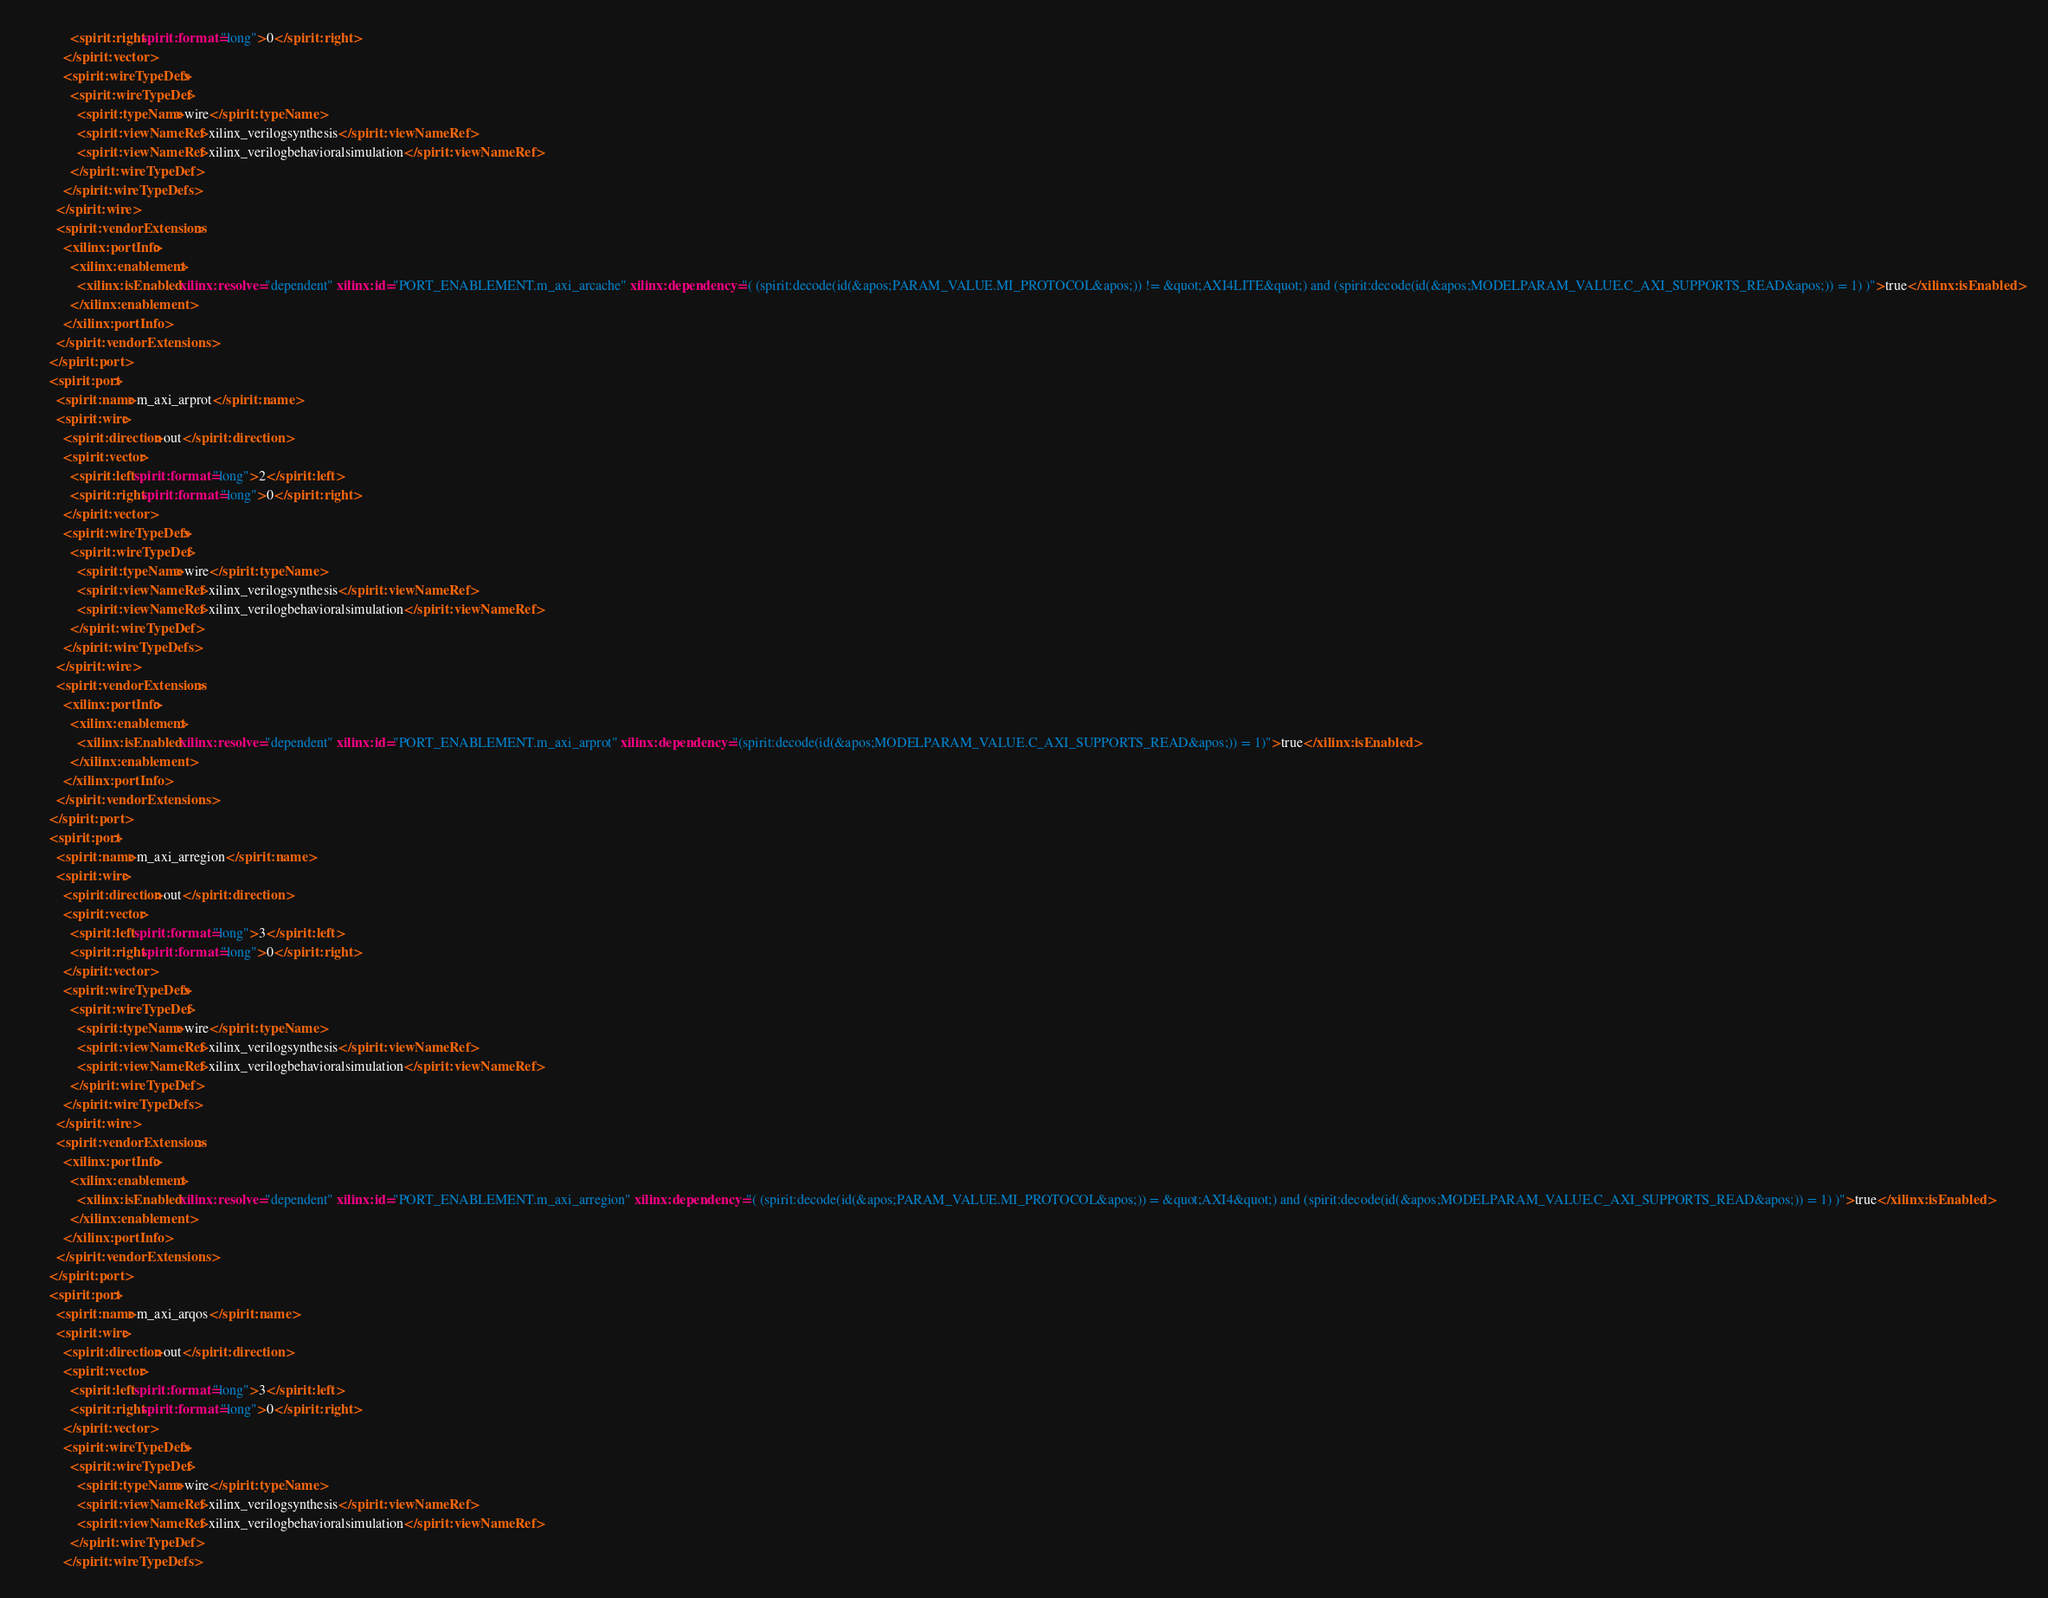Convert code to text. <code><loc_0><loc_0><loc_500><loc_500><_XML_>            <spirit:right spirit:format="long">0</spirit:right>
          </spirit:vector>
          <spirit:wireTypeDefs>
            <spirit:wireTypeDef>
              <spirit:typeName>wire</spirit:typeName>
              <spirit:viewNameRef>xilinx_verilogsynthesis</spirit:viewNameRef>
              <spirit:viewNameRef>xilinx_verilogbehavioralsimulation</spirit:viewNameRef>
            </spirit:wireTypeDef>
          </spirit:wireTypeDefs>
        </spirit:wire>
        <spirit:vendorExtensions>
          <xilinx:portInfo>
            <xilinx:enablement>
              <xilinx:isEnabled xilinx:resolve="dependent" xilinx:id="PORT_ENABLEMENT.m_axi_arcache" xilinx:dependency="( (spirit:decode(id(&apos;PARAM_VALUE.MI_PROTOCOL&apos;)) != &quot;AXI4LITE&quot;) and (spirit:decode(id(&apos;MODELPARAM_VALUE.C_AXI_SUPPORTS_READ&apos;)) = 1) )">true</xilinx:isEnabled>
            </xilinx:enablement>
          </xilinx:portInfo>
        </spirit:vendorExtensions>
      </spirit:port>
      <spirit:port>
        <spirit:name>m_axi_arprot</spirit:name>
        <spirit:wire>
          <spirit:direction>out</spirit:direction>
          <spirit:vector>
            <spirit:left spirit:format="long">2</spirit:left>
            <spirit:right spirit:format="long">0</spirit:right>
          </spirit:vector>
          <spirit:wireTypeDefs>
            <spirit:wireTypeDef>
              <spirit:typeName>wire</spirit:typeName>
              <spirit:viewNameRef>xilinx_verilogsynthesis</spirit:viewNameRef>
              <spirit:viewNameRef>xilinx_verilogbehavioralsimulation</spirit:viewNameRef>
            </spirit:wireTypeDef>
          </spirit:wireTypeDefs>
        </spirit:wire>
        <spirit:vendorExtensions>
          <xilinx:portInfo>
            <xilinx:enablement>
              <xilinx:isEnabled xilinx:resolve="dependent" xilinx:id="PORT_ENABLEMENT.m_axi_arprot" xilinx:dependency="(spirit:decode(id(&apos;MODELPARAM_VALUE.C_AXI_SUPPORTS_READ&apos;)) = 1)">true</xilinx:isEnabled>
            </xilinx:enablement>
          </xilinx:portInfo>
        </spirit:vendorExtensions>
      </spirit:port>
      <spirit:port>
        <spirit:name>m_axi_arregion</spirit:name>
        <spirit:wire>
          <spirit:direction>out</spirit:direction>
          <spirit:vector>
            <spirit:left spirit:format="long">3</spirit:left>
            <spirit:right spirit:format="long">0</spirit:right>
          </spirit:vector>
          <spirit:wireTypeDefs>
            <spirit:wireTypeDef>
              <spirit:typeName>wire</spirit:typeName>
              <spirit:viewNameRef>xilinx_verilogsynthesis</spirit:viewNameRef>
              <spirit:viewNameRef>xilinx_verilogbehavioralsimulation</spirit:viewNameRef>
            </spirit:wireTypeDef>
          </spirit:wireTypeDefs>
        </spirit:wire>
        <spirit:vendorExtensions>
          <xilinx:portInfo>
            <xilinx:enablement>
              <xilinx:isEnabled xilinx:resolve="dependent" xilinx:id="PORT_ENABLEMENT.m_axi_arregion" xilinx:dependency="( (spirit:decode(id(&apos;PARAM_VALUE.MI_PROTOCOL&apos;)) = &quot;AXI4&quot;) and (spirit:decode(id(&apos;MODELPARAM_VALUE.C_AXI_SUPPORTS_READ&apos;)) = 1) )">true</xilinx:isEnabled>
            </xilinx:enablement>
          </xilinx:portInfo>
        </spirit:vendorExtensions>
      </spirit:port>
      <spirit:port>
        <spirit:name>m_axi_arqos</spirit:name>
        <spirit:wire>
          <spirit:direction>out</spirit:direction>
          <spirit:vector>
            <spirit:left spirit:format="long">3</spirit:left>
            <spirit:right spirit:format="long">0</spirit:right>
          </spirit:vector>
          <spirit:wireTypeDefs>
            <spirit:wireTypeDef>
              <spirit:typeName>wire</spirit:typeName>
              <spirit:viewNameRef>xilinx_verilogsynthesis</spirit:viewNameRef>
              <spirit:viewNameRef>xilinx_verilogbehavioralsimulation</spirit:viewNameRef>
            </spirit:wireTypeDef>
          </spirit:wireTypeDefs></code> 